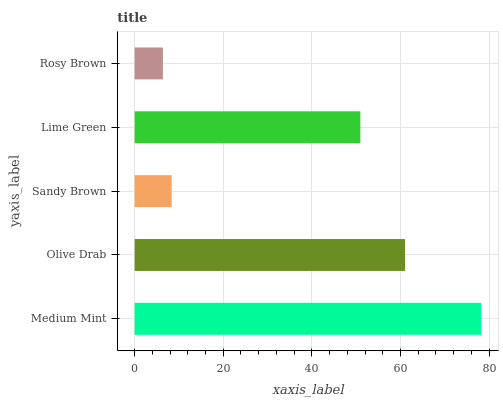Is Rosy Brown the minimum?
Answer yes or no. Yes. Is Medium Mint the maximum?
Answer yes or no. Yes. Is Olive Drab the minimum?
Answer yes or no. No. Is Olive Drab the maximum?
Answer yes or no. No. Is Medium Mint greater than Olive Drab?
Answer yes or no. Yes. Is Olive Drab less than Medium Mint?
Answer yes or no. Yes. Is Olive Drab greater than Medium Mint?
Answer yes or no. No. Is Medium Mint less than Olive Drab?
Answer yes or no. No. Is Lime Green the high median?
Answer yes or no. Yes. Is Lime Green the low median?
Answer yes or no. Yes. Is Sandy Brown the high median?
Answer yes or no. No. Is Olive Drab the low median?
Answer yes or no. No. 